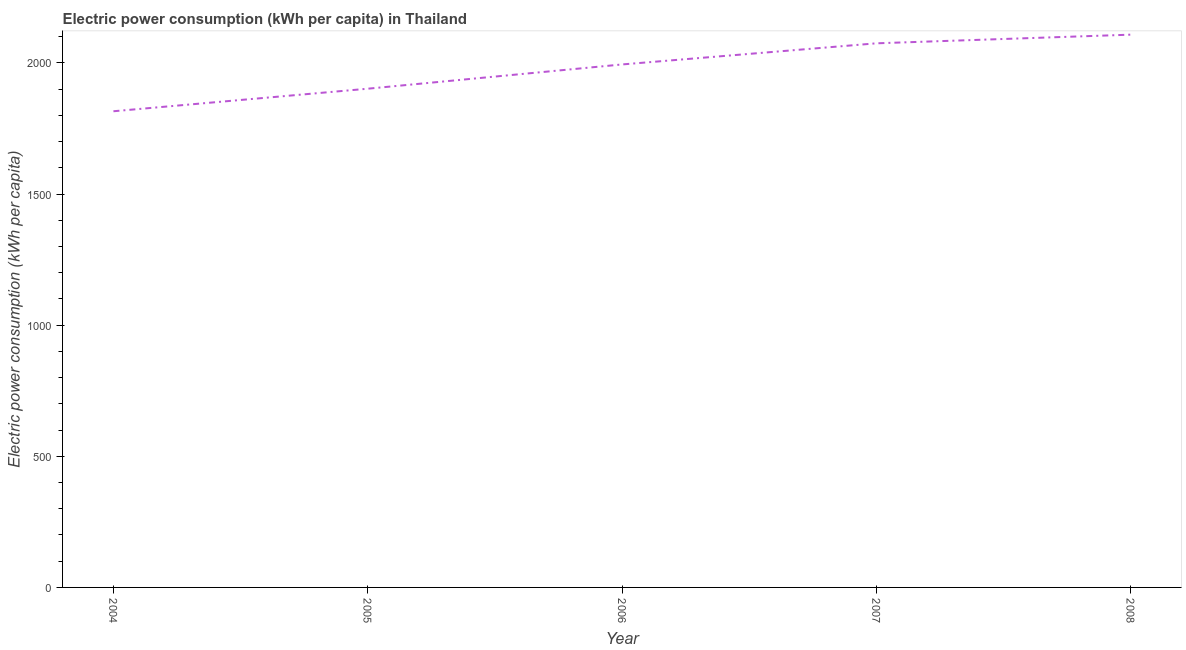What is the electric power consumption in 2004?
Keep it short and to the point. 1815.81. Across all years, what is the maximum electric power consumption?
Your answer should be very brief. 2107.9. Across all years, what is the minimum electric power consumption?
Offer a terse response. 1815.81. In which year was the electric power consumption maximum?
Offer a very short reply. 2008. What is the sum of the electric power consumption?
Ensure brevity in your answer.  9894.65. What is the difference between the electric power consumption in 2004 and 2005?
Offer a very short reply. -85.98. What is the average electric power consumption per year?
Your answer should be very brief. 1978.93. What is the median electric power consumption?
Keep it short and to the point. 1994.29. In how many years, is the electric power consumption greater than 2000 kWh per capita?
Make the answer very short. 2. What is the ratio of the electric power consumption in 2007 to that in 2008?
Keep it short and to the point. 0.98. Is the electric power consumption in 2004 less than that in 2008?
Provide a succinct answer. Yes. Is the difference between the electric power consumption in 2004 and 2008 greater than the difference between any two years?
Your answer should be very brief. Yes. What is the difference between the highest and the second highest electric power consumption?
Your response must be concise. 33.03. Is the sum of the electric power consumption in 2004 and 2007 greater than the maximum electric power consumption across all years?
Ensure brevity in your answer.  Yes. What is the difference between the highest and the lowest electric power consumption?
Your response must be concise. 292.1. In how many years, is the electric power consumption greater than the average electric power consumption taken over all years?
Provide a succinct answer. 3. How many lines are there?
Offer a terse response. 1. What is the difference between two consecutive major ticks on the Y-axis?
Your response must be concise. 500. Are the values on the major ticks of Y-axis written in scientific E-notation?
Provide a short and direct response. No. What is the title of the graph?
Your response must be concise. Electric power consumption (kWh per capita) in Thailand. What is the label or title of the Y-axis?
Your response must be concise. Electric power consumption (kWh per capita). What is the Electric power consumption (kWh per capita) in 2004?
Provide a succinct answer. 1815.81. What is the Electric power consumption (kWh per capita) of 2005?
Offer a very short reply. 1901.78. What is the Electric power consumption (kWh per capita) in 2006?
Offer a very short reply. 1994.29. What is the Electric power consumption (kWh per capita) in 2007?
Keep it short and to the point. 2074.87. What is the Electric power consumption (kWh per capita) of 2008?
Your response must be concise. 2107.9. What is the difference between the Electric power consumption (kWh per capita) in 2004 and 2005?
Give a very brief answer. -85.98. What is the difference between the Electric power consumption (kWh per capita) in 2004 and 2006?
Keep it short and to the point. -178.48. What is the difference between the Electric power consumption (kWh per capita) in 2004 and 2007?
Your response must be concise. -259.06. What is the difference between the Electric power consumption (kWh per capita) in 2004 and 2008?
Keep it short and to the point. -292.1. What is the difference between the Electric power consumption (kWh per capita) in 2005 and 2006?
Provide a short and direct response. -92.51. What is the difference between the Electric power consumption (kWh per capita) in 2005 and 2007?
Offer a terse response. -173.09. What is the difference between the Electric power consumption (kWh per capita) in 2005 and 2008?
Make the answer very short. -206.12. What is the difference between the Electric power consumption (kWh per capita) in 2006 and 2007?
Make the answer very short. -80.58. What is the difference between the Electric power consumption (kWh per capita) in 2006 and 2008?
Your response must be concise. -113.61. What is the difference between the Electric power consumption (kWh per capita) in 2007 and 2008?
Offer a very short reply. -33.03. What is the ratio of the Electric power consumption (kWh per capita) in 2004 to that in 2005?
Ensure brevity in your answer.  0.95. What is the ratio of the Electric power consumption (kWh per capita) in 2004 to that in 2006?
Provide a succinct answer. 0.91. What is the ratio of the Electric power consumption (kWh per capita) in 2004 to that in 2008?
Ensure brevity in your answer.  0.86. What is the ratio of the Electric power consumption (kWh per capita) in 2005 to that in 2006?
Your answer should be compact. 0.95. What is the ratio of the Electric power consumption (kWh per capita) in 2005 to that in 2007?
Your response must be concise. 0.92. What is the ratio of the Electric power consumption (kWh per capita) in 2005 to that in 2008?
Provide a succinct answer. 0.9. What is the ratio of the Electric power consumption (kWh per capita) in 2006 to that in 2008?
Provide a succinct answer. 0.95. 